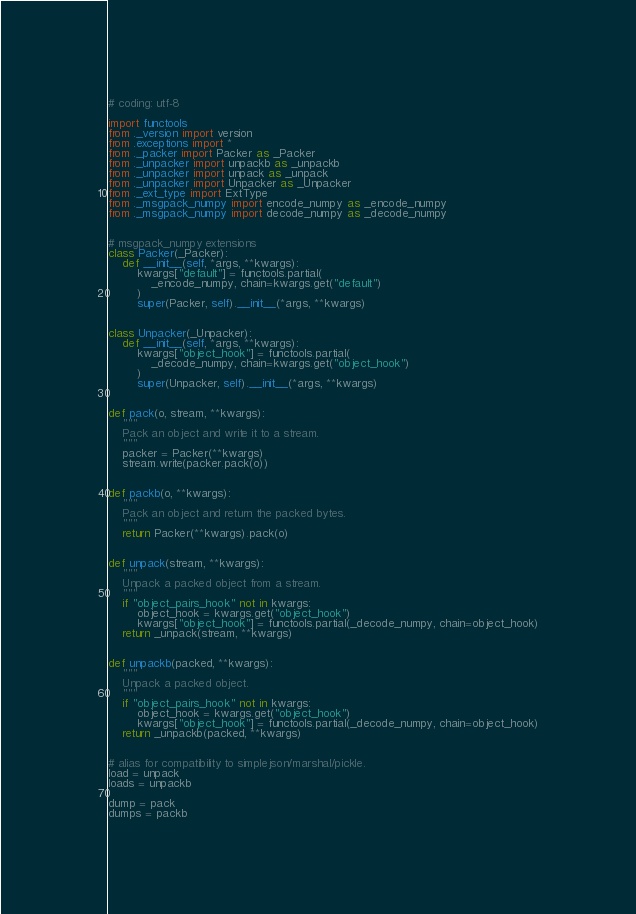Convert code to text. <code><loc_0><loc_0><loc_500><loc_500><_Python_># coding: utf-8

import functools
from ._version import version
from .exceptions import *
from ._packer import Packer as _Packer
from ._unpacker import unpackb as _unpackb
from ._unpacker import unpack as _unpack
from ._unpacker import Unpacker as _Unpacker
from ._ext_type import ExtType
from ._msgpack_numpy import encode_numpy as _encode_numpy
from ._msgpack_numpy import decode_numpy as _decode_numpy


# msgpack_numpy extensions
class Packer(_Packer):
    def __init__(self, *args, **kwargs):
        kwargs["default"] = functools.partial(
            _encode_numpy, chain=kwargs.get("default")
        )
        super(Packer, self).__init__(*args, **kwargs)


class Unpacker(_Unpacker):
    def __init__(self, *args, **kwargs):
        kwargs["object_hook"] = functools.partial(
            _decode_numpy, chain=kwargs.get("object_hook")
        )
        super(Unpacker, self).__init__(*args, **kwargs)


def pack(o, stream, **kwargs):
    """
    Pack an object and write it to a stream.
    """
    packer = Packer(**kwargs)
    stream.write(packer.pack(o))


def packb(o, **kwargs):
    """
    Pack an object and return the packed bytes.
    """
    return Packer(**kwargs).pack(o)


def unpack(stream, **kwargs):
    """
    Unpack a packed object from a stream.
    """
    if "object_pairs_hook" not in kwargs:
        object_hook = kwargs.get("object_hook")
        kwargs["object_hook"] = functools.partial(_decode_numpy, chain=object_hook)
    return _unpack(stream, **kwargs)


def unpackb(packed, **kwargs):
    """
    Unpack a packed object.
    """
    if "object_pairs_hook" not in kwargs:
        object_hook = kwargs.get("object_hook")
        kwargs["object_hook"] = functools.partial(_decode_numpy, chain=object_hook)
    return _unpackb(packed, **kwargs)


# alias for compatibility to simplejson/marshal/pickle.
load = unpack
loads = unpackb

dump = pack
dumps = packb
</code> 